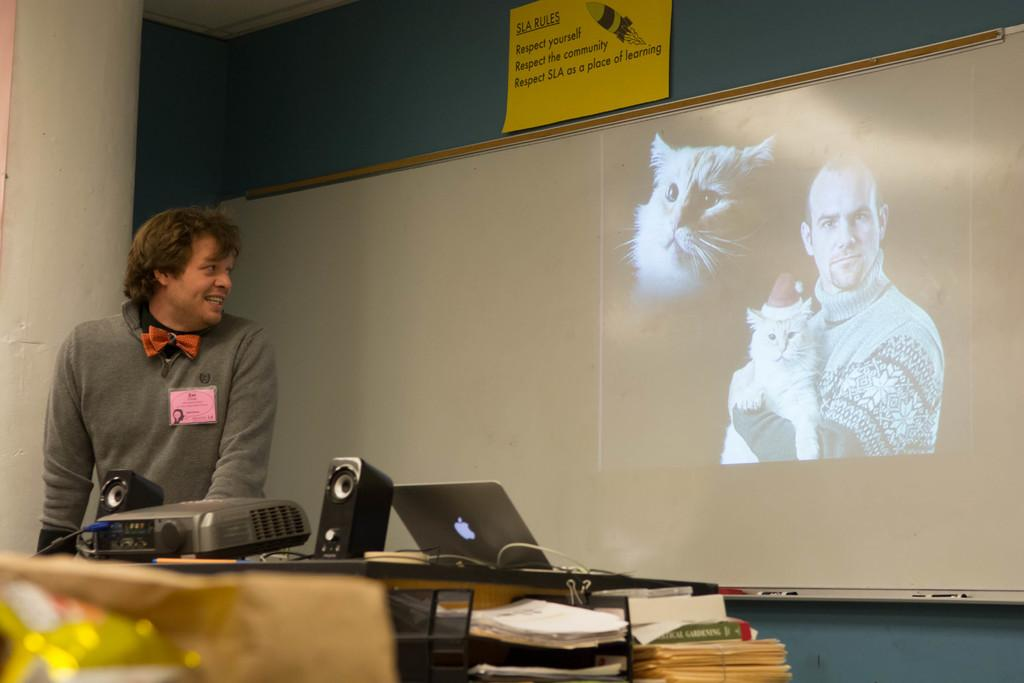<image>
Render a clear and concise summary of the photo. A man standing in front of an image of a man holding a cat in front of an SLA rules sign. 